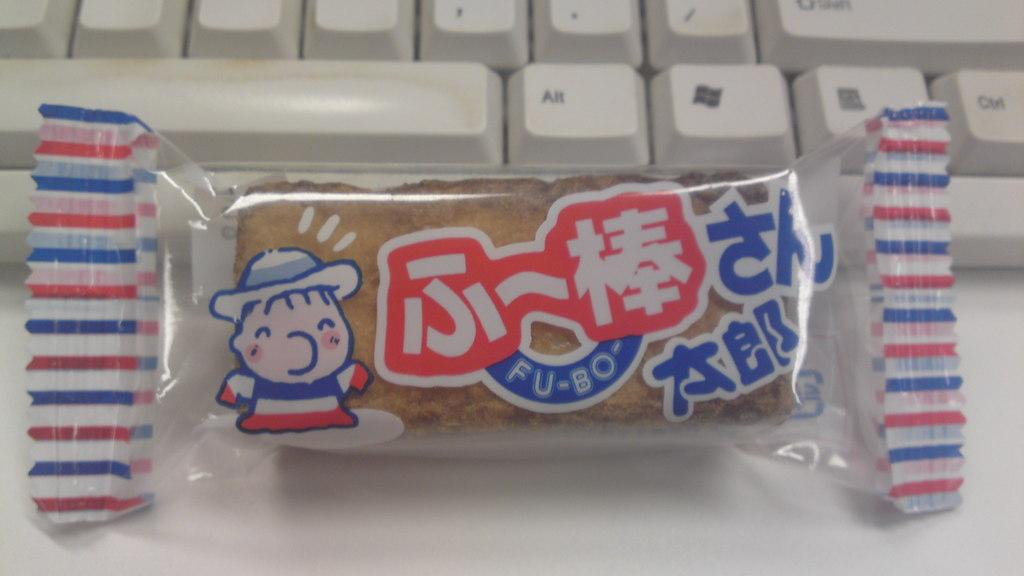What is inside the packets that are visible in the image? The packets contain biscuits. What else can be seen in the image besides the packets? There is a keyboard in the background of the image. What is the surface on which the packets are placed? There is a table at the bottom of the image. Can you hear the music being played on the keyboard in the image? There is no sound or indication of music being played in the image; it is a still photograph. 